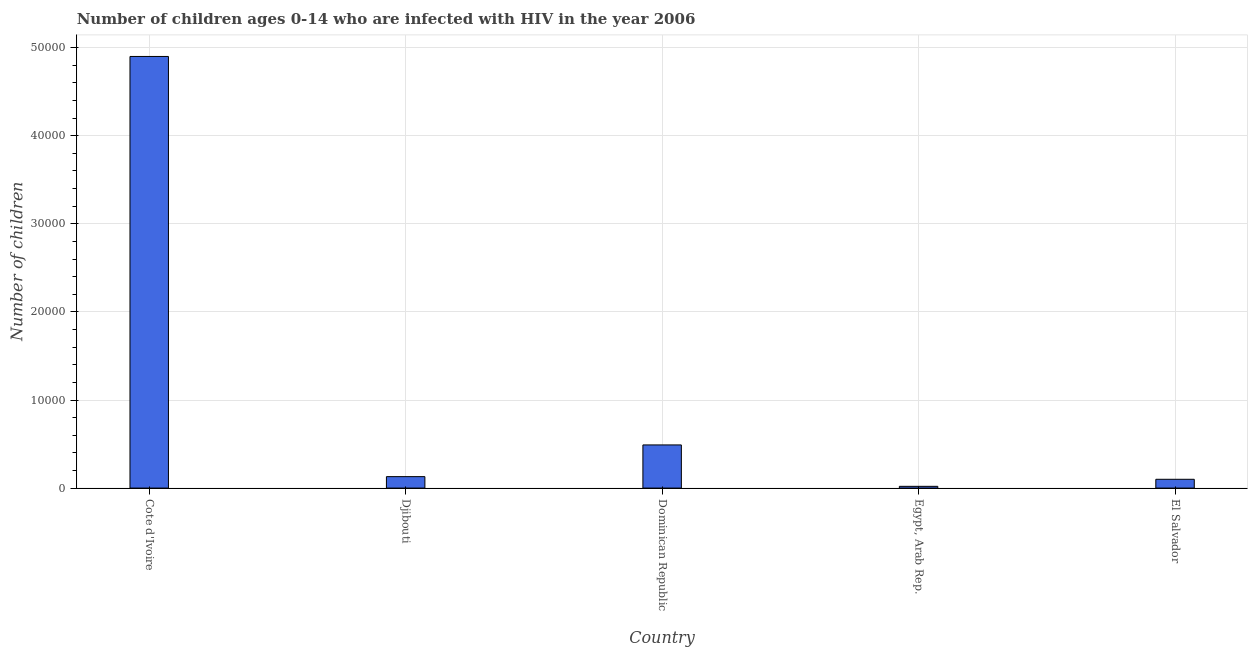Does the graph contain grids?
Provide a short and direct response. Yes. What is the title of the graph?
Your response must be concise. Number of children ages 0-14 who are infected with HIV in the year 2006. What is the label or title of the X-axis?
Give a very brief answer. Country. What is the label or title of the Y-axis?
Provide a short and direct response. Number of children. What is the number of children living with hiv in Djibouti?
Keep it short and to the point. 1300. Across all countries, what is the maximum number of children living with hiv?
Your answer should be compact. 4.90e+04. Across all countries, what is the minimum number of children living with hiv?
Your answer should be compact. 200. In which country was the number of children living with hiv maximum?
Ensure brevity in your answer.  Cote d'Ivoire. In which country was the number of children living with hiv minimum?
Give a very brief answer. Egypt, Arab Rep. What is the sum of the number of children living with hiv?
Make the answer very short. 5.64e+04. What is the difference between the number of children living with hiv in Djibouti and El Salvador?
Provide a succinct answer. 300. What is the average number of children living with hiv per country?
Keep it short and to the point. 1.13e+04. What is the median number of children living with hiv?
Keep it short and to the point. 1300. What is the ratio of the number of children living with hiv in Egypt, Arab Rep. to that in El Salvador?
Your response must be concise. 0.2. Is the difference between the number of children living with hiv in Dominican Republic and El Salvador greater than the difference between any two countries?
Give a very brief answer. No. What is the difference between the highest and the second highest number of children living with hiv?
Offer a terse response. 4.41e+04. Is the sum of the number of children living with hiv in Dominican Republic and El Salvador greater than the maximum number of children living with hiv across all countries?
Keep it short and to the point. No. What is the difference between the highest and the lowest number of children living with hiv?
Your answer should be compact. 4.88e+04. In how many countries, is the number of children living with hiv greater than the average number of children living with hiv taken over all countries?
Your response must be concise. 1. How many bars are there?
Your answer should be compact. 5. Are all the bars in the graph horizontal?
Provide a short and direct response. No. How many countries are there in the graph?
Offer a terse response. 5. What is the difference between two consecutive major ticks on the Y-axis?
Your response must be concise. 10000. Are the values on the major ticks of Y-axis written in scientific E-notation?
Give a very brief answer. No. What is the Number of children in Cote d'Ivoire?
Offer a very short reply. 4.90e+04. What is the Number of children of Djibouti?
Make the answer very short. 1300. What is the Number of children of Dominican Republic?
Give a very brief answer. 4900. What is the Number of children in El Salvador?
Your response must be concise. 1000. What is the difference between the Number of children in Cote d'Ivoire and Djibouti?
Provide a short and direct response. 4.77e+04. What is the difference between the Number of children in Cote d'Ivoire and Dominican Republic?
Offer a terse response. 4.41e+04. What is the difference between the Number of children in Cote d'Ivoire and Egypt, Arab Rep.?
Give a very brief answer. 4.88e+04. What is the difference between the Number of children in Cote d'Ivoire and El Salvador?
Offer a very short reply. 4.80e+04. What is the difference between the Number of children in Djibouti and Dominican Republic?
Offer a terse response. -3600. What is the difference between the Number of children in Djibouti and Egypt, Arab Rep.?
Your response must be concise. 1100. What is the difference between the Number of children in Djibouti and El Salvador?
Your answer should be very brief. 300. What is the difference between the Number of children in Dominican Republic and Egypt, Arab Rep.?
Your response must be concise. 4700. What is the difference between the Number of children in Dominican Republic and El Salvador?
Keep it short and to the point. 3900. What is the difference between the Number of children in Egypt, Arab Rep. and El Salvador?
Give a very brief answer. -800. What is the ratio of the Number of children in Cote d'Ivoire to that in Djibouti?
Your answer should be very brief. 37.69. What is the ratio of the Number of children in Cote d'Ivoire to that in Dominican Republic?
Your answer should be very brief. 10. What is the ratio of the Number of children in Cote d'Ivoire to that in Egypt, Arab Rep.?
Provide a short and direct response. 245. What is the ratio of the Number of children in Cote d'Ivoire to that in El Salvador?
Your answer should be very brief. 49. What is the ratio of the Number of children in Djibouti to that in Dominican Republic?
Give a very brief answer. 0.27. What is the ratio of the Number of children in Djibouti to that in Egypt, Arab Rep.?
Offer a terse response. 6.5. What is the ratio of the Number of children in Dominican Republic to that in El Salvador?
Your response must be concise. 4.9. What is the ratio of the Number of children in Egypt, Arab Rep. to that in El Salvador?
Your answer should be compact. 0.2. 